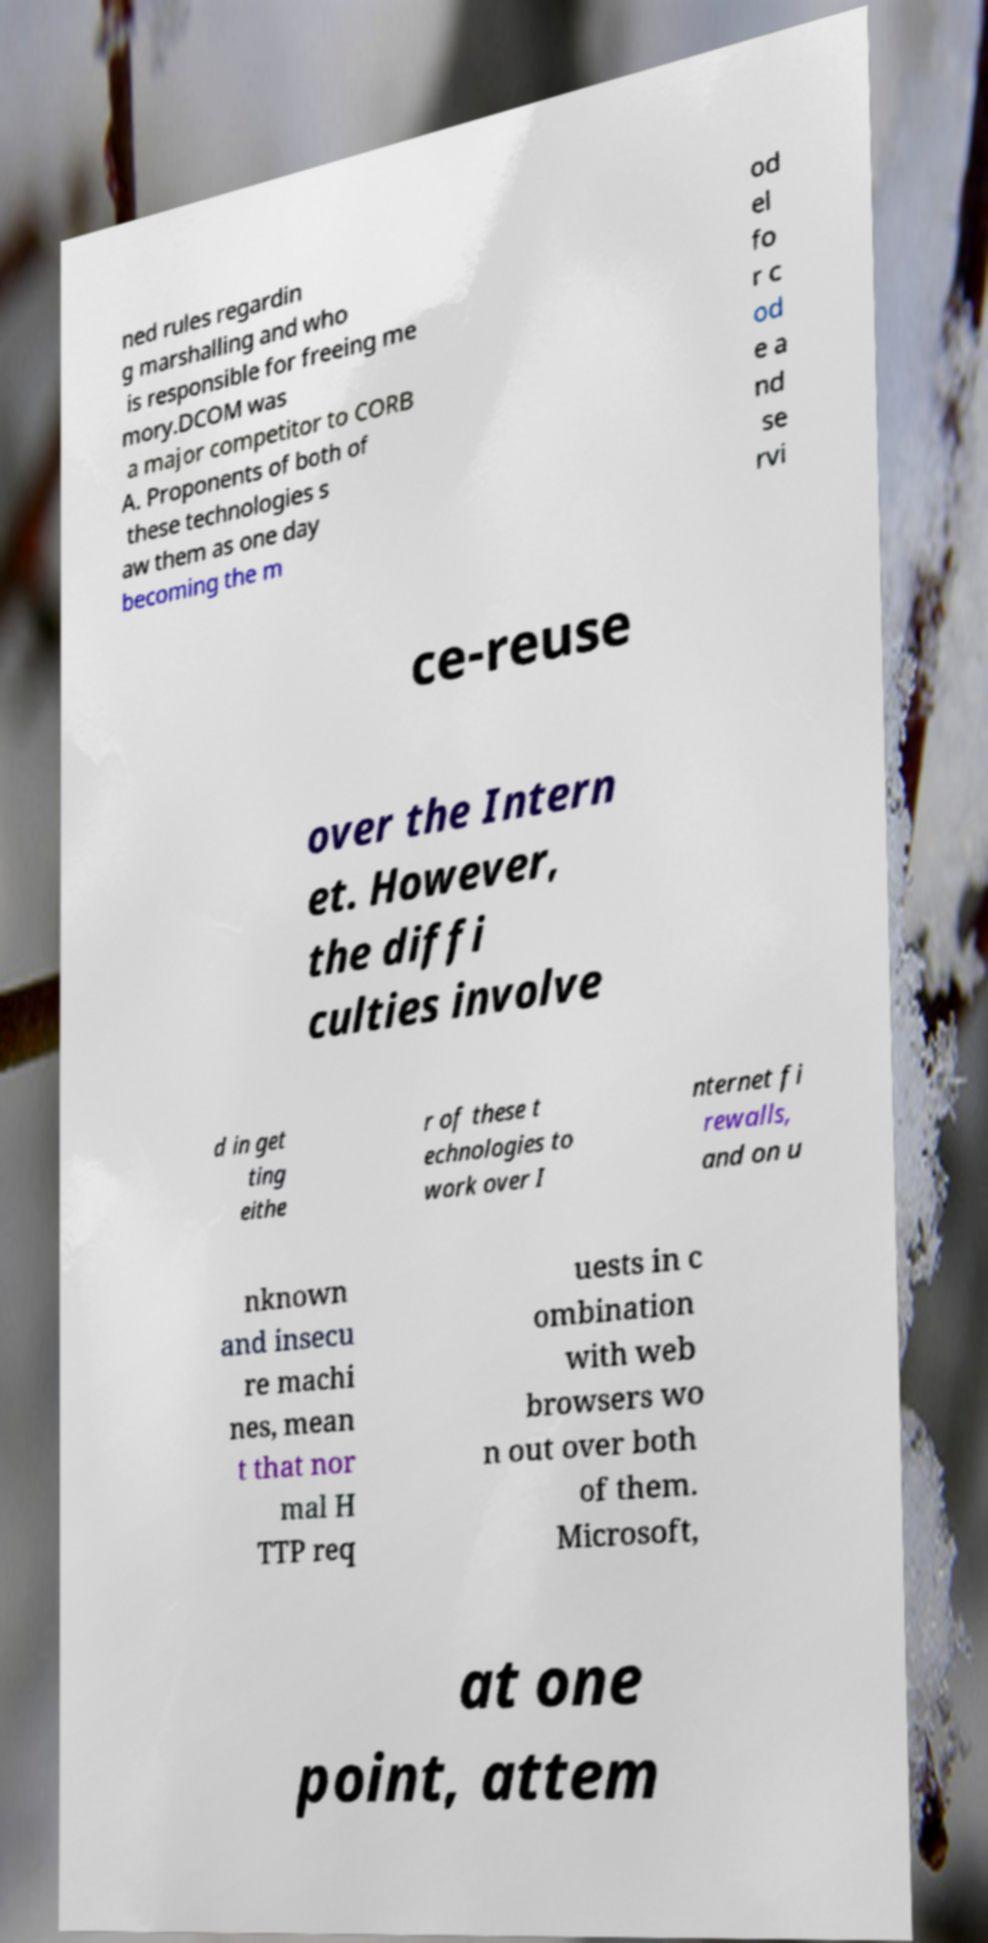What messages or text are displayed in this image? I need them in a readable, typed format. ned rules regardin g marshalling and who is responsible for freeing me mory.DCOM was a major competitor to CORB A. Proponents of both of these technologies s aw them as one day becoming the m od el fo r c od e a nd se rvi ce-reuse over the Intern et. However, the diffi culties involve d in get ting eithe r of these t echnologies to work over I nternet fi rewalls, and on u nknown and insecu re machi nes, mean t that nor mal H TTP req uests in c ombination with web browsers wo n out over both of them. Microsoft, at one point, attem 